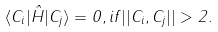<formula> <loc_0><loc_0><loc_500><loc_500>\langle C _ { i } | \hat { H } | C _ { j } \rangle = 0 , i f | | C _ { i } , C _ { j } | | > 2 .</formula> 